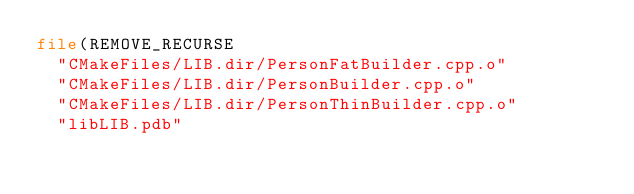<code> <loc_0><loc_0><loc_500><loc_500><_CMake_>file(REMOVE_RECURSE
  "CMakeFiles/LIB.dir/PersonFatBuilder.cpp.o"
  "CMakeFiles/LIB.dir/PersonBuilder.cpp.o"
  "CMakeFiles/LIB.dir/PersonThinBuilder.cpp.o"
  "libLIB.pdb"</code> 